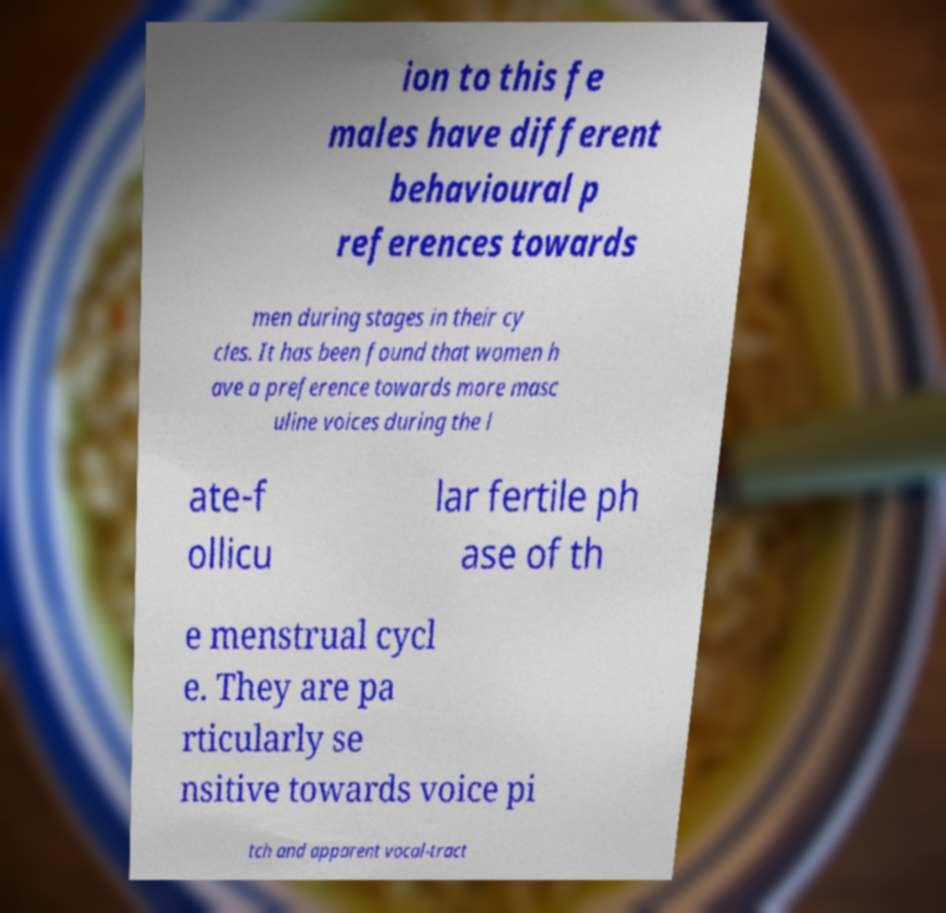There's text embedded in this image that I need extracted. Can you transcribe it verbatim? ion to this fe males have different behavioural p references towards men during stages in their cy cles. It has been found that women h ave a preference towards more masc uline voices during the l ate-f ollicu lar fertile ph ase of th e menstrual cycl e. They are pa rticularly se nsitive towards voice pi tch and apparent vocal-tract 